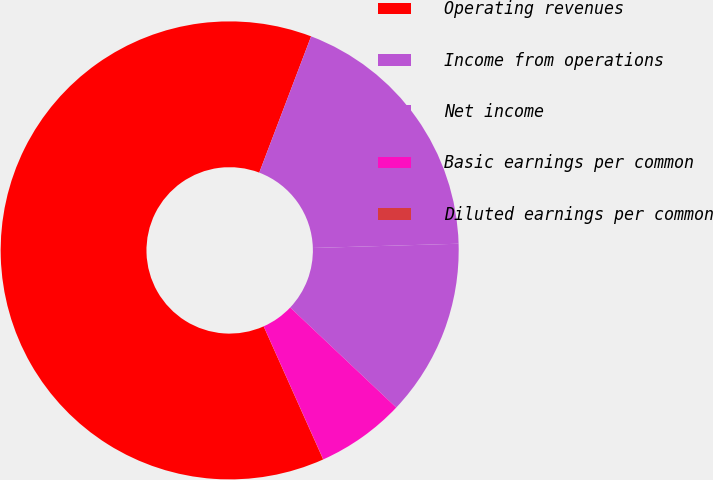<chart> <loc_0><loc_0><loc_500><loc_500><pie_chart><fcel>Operating revenues<fcel>Income from operations<fcel>Net income<fcel>Basic earnings per common<fcel>Diluted earnings per common<nl><fcel>62.48%<fcel>18.75%<fcel>12.5%<fcel>6.26%<fcel>0.01%<nl></chart> 